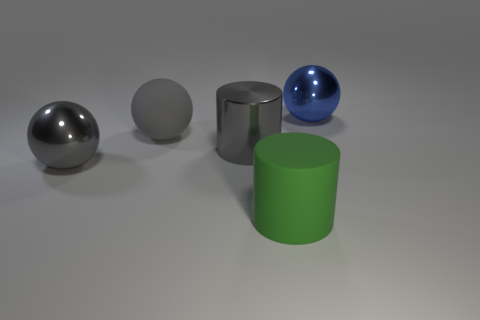Add 1 large blue metal spheres. How many objects exist? 6 Subtract all cylinders. How many objects are left? 3 Add 1 gray matte spheres. How many gray matte spheres are left? 2 Add 2 large blue metal spheres. How many large blue metal spheres exist? 3 Subtract 1 blue spheres. How many objects are left? 4 Subtract all big metal things. Subtract all tiny yellow balls. How many objects are left? 2 